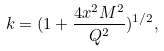Convert formula to latex. <formula><loc_0><loc_0><loc_500><loc_500>k = ( 1 + \frac { 4 x ^ { 2 } M ^ { 2 } } { Q ^ { 2 } } ) ^ { 1 / 2 } ,</formula> 